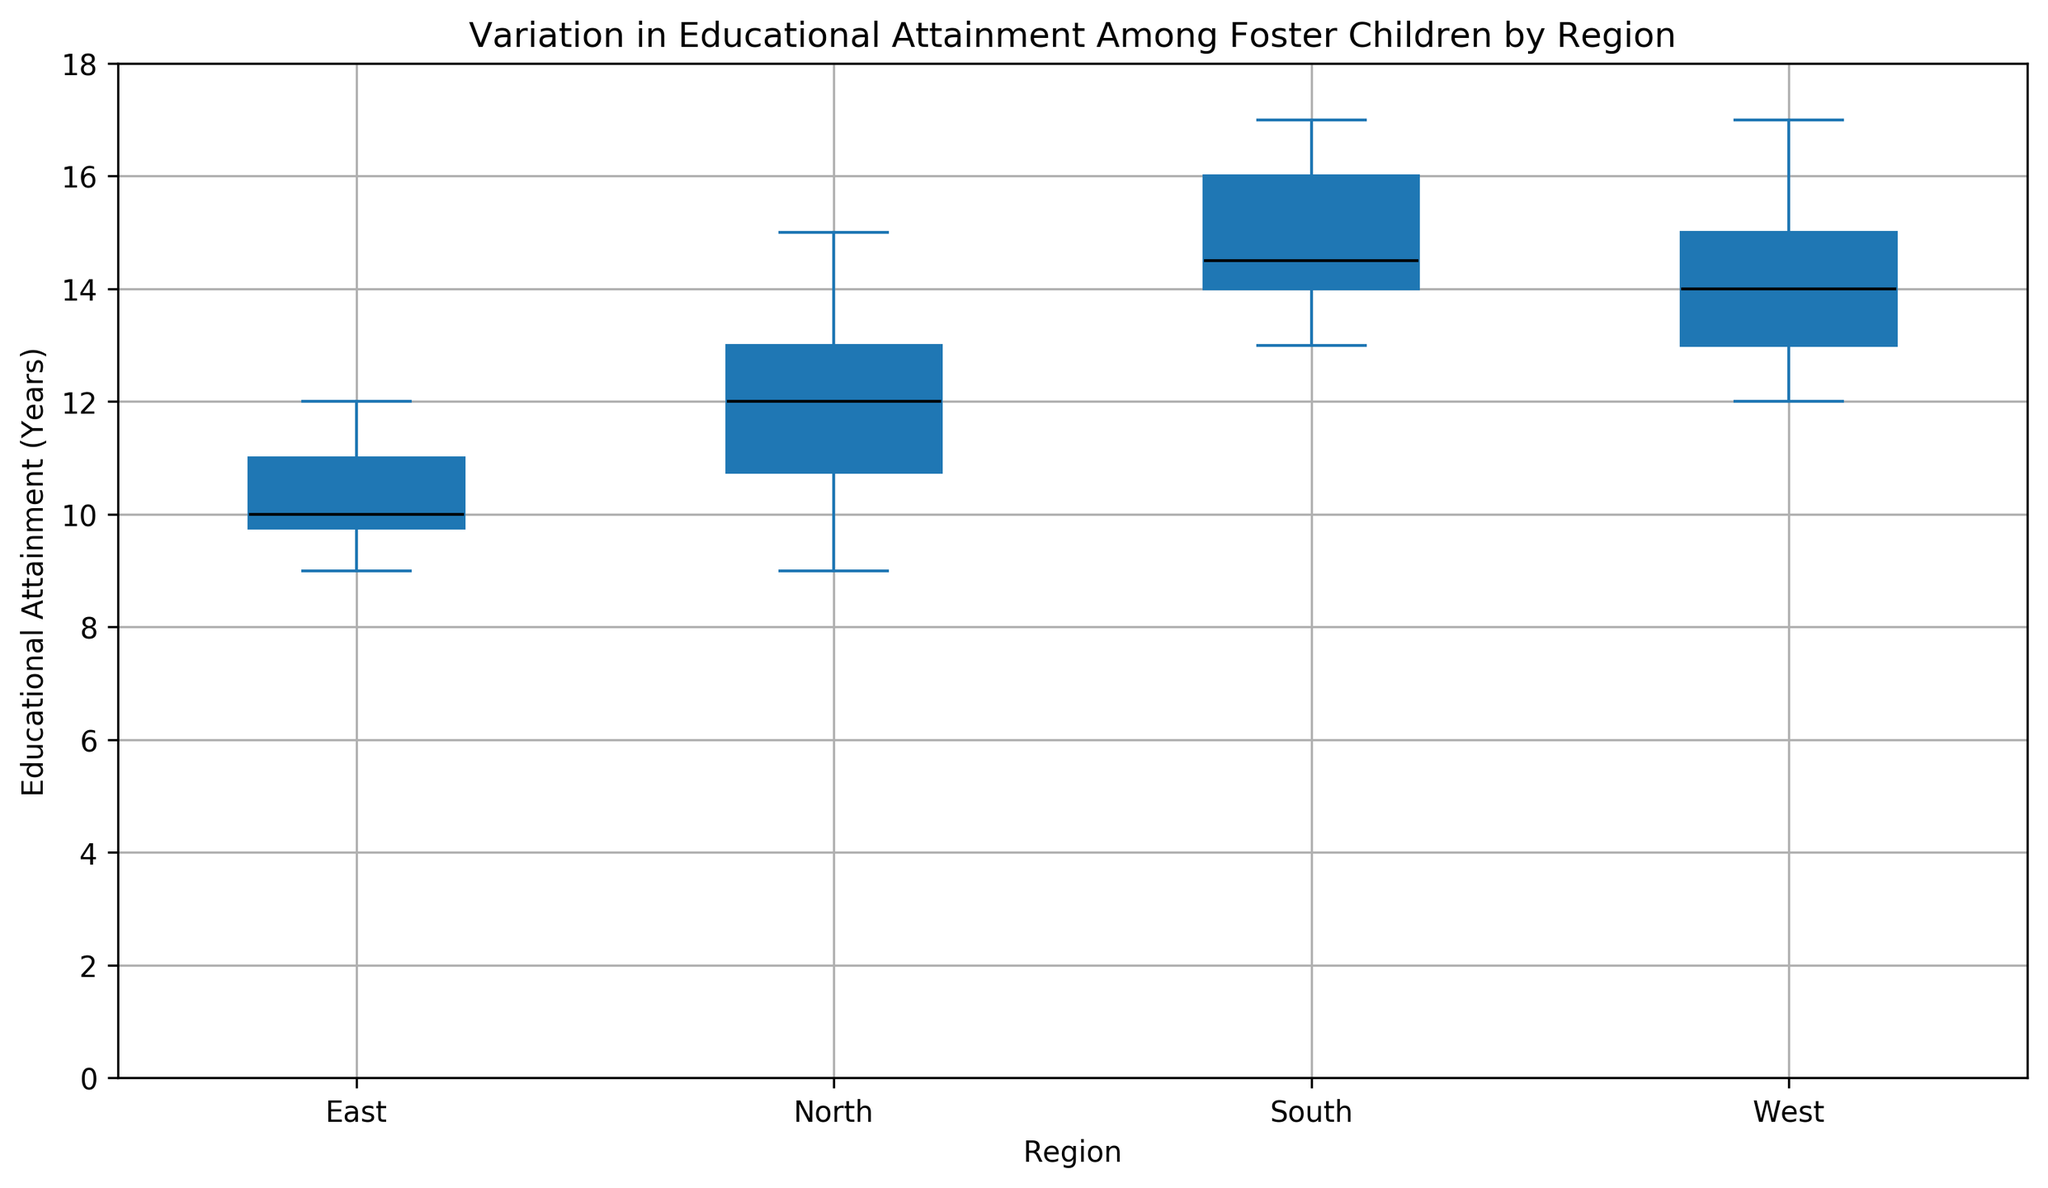What is the median educational attainment in the North region? Locate the 'North' region on the figure and identify the line that divides the box (which represents the interquartile range) into two. This line is the median.
Answer: 12 Which region has the highest median educational attainment? Compare the median lines of the boxes for each region visible in the plot. The highest median line will be the answer.
Answer: South Between which two regions is the difference in median educational attainment the greatest? Calculate the difference in median values for each pair of regions by observing the median lines in the boxes. The two regions with the largest gap between medians will have the greatest difference.
Answer: East and South Which region has the greatest range of educational attainment? The range is indicated by the distance between the bottom whisker and the top whisker of the box plot. The region with the longest whiskers has the greatest range.
Answer: West Which region has the smallest interquartile range (IQR) for educational attainment? The IQR is the difference between the third quartile (top of the box) and the first quartile (bottom of the box). The region with the shortest box width has the smallest IQR.
Answer: East How does the variability in educational attainment in the South compare to that in the North? Look at the length of the whiskers and the interquartile range (IQR) for both South and North regions in the figure.
Answer: The South has a higher variability Which region shows the most outliers for educational attainment? Outliers are typically marked as individual points outside the whiskers. Count the number of outlier points for each region.
Answer: North What is the range of educational attainment in the East region? The range is from the bottom whisker to the top whisker for the East region. Identify these points to compute the range.
Answer: 3 (9 to 12) How does the upper quartile of the North region compare to the upper quartile of the South region? Compare the top of the box (75th percentile) for both the North and South regions.
Answer: The South's is higher Which region has the closest median to the upper quartile of the East region? Find the median values of all regions and compare them with the top of the box of the East region. The closest value to the East's upper quartile will be your answer.
Answer: North 